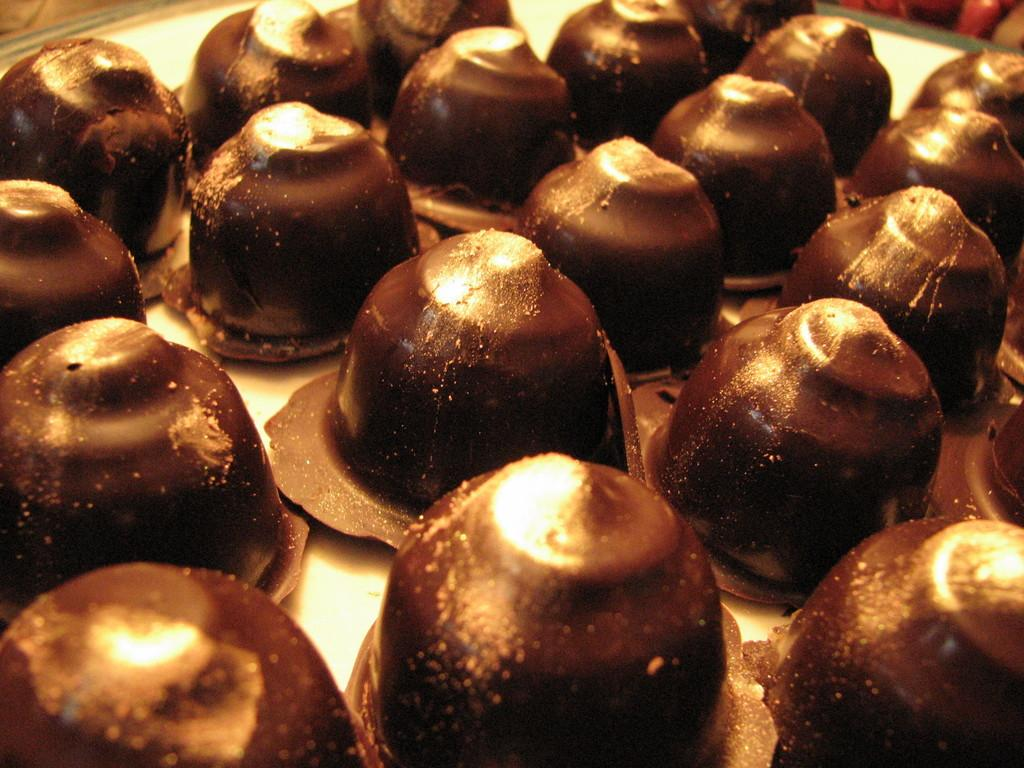What can be seen in the image? There are food items in the image. Where are the food items located? The food items are on a platform. What type of bone can be seen in the image? There is no bone present in the image; it only features food items on a platform. 